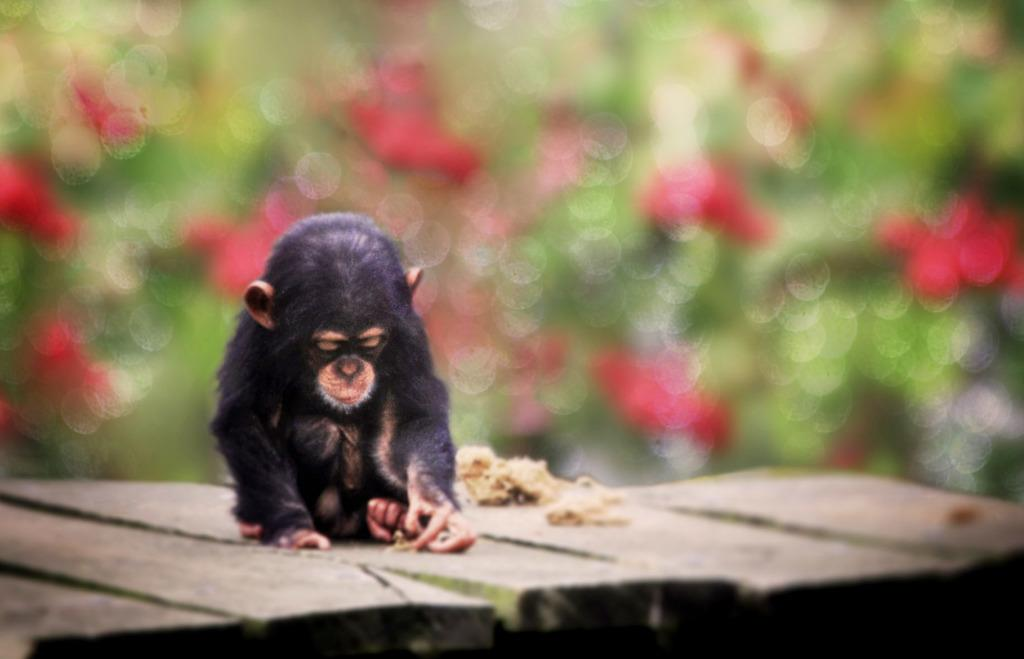What animal is present in the image? There is a monkey in the image. What type of surface is the monkey on? The monkey is on a wooden surface. Can you describe the background of the image? The background of the image is blurred. What type of plastic material can be seen in the image? There is no plastic material present in the image. What is the weight of the monkey in the image? It is not possible to determine the weight of the monkey from the image alone. 